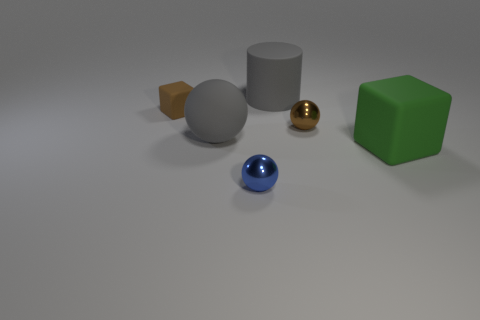There is a big gray rubber ball; are there any things behind it?
Provide a short and direct response. Yes. How many big matte balls are there?
Your answer should be compact. 1. There is a cube behind the big rubber cube; how many matte cubes are behind it?
Ensure brevity in your answer.  0. There is a large rubber sphere; is its color the same as the big object that is behind the brown ball?
Keep it short and to the point. Yes. How many small brown matte things have the same shape as the big green matte thing?
Your answer should be very brief. 1. What material is the brown thing that is behind the tiny brown shiny sphere?
Provide a succinct answer. Rubber. There is a gray rubber object on the left side of the tiny blue ball; is its shape the same as the blue metal object?
Provide a short and direct response. Yes. Are there any green rubber things of the same size as the gray matte cylinder?
Make the answer very short. Yes. Do the tiny blue metallic object and the gray thing that is in front of the tiny brown ball have the same shape?
Make the answer very short. Yes. There is a big rubber thing that is the same color as the rubber sphere; what is its shape?
Your response must be concise. Cylinder. 